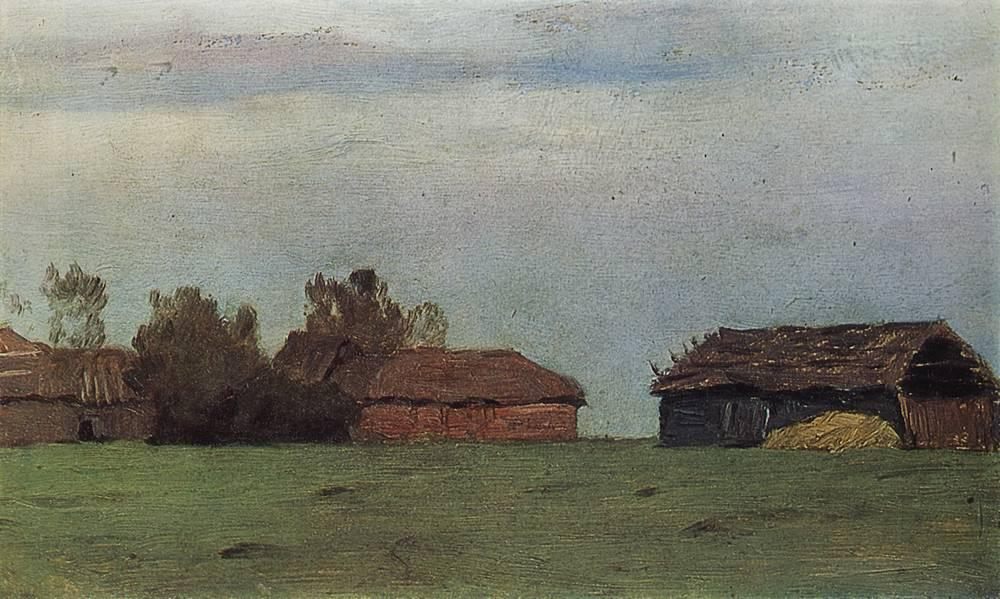What time of day does this painting depict? The painting appears to depict either early morning or late afternoon, as indicated by the soft, diffused light and long shadows that suggest the sun is low in the sky. 